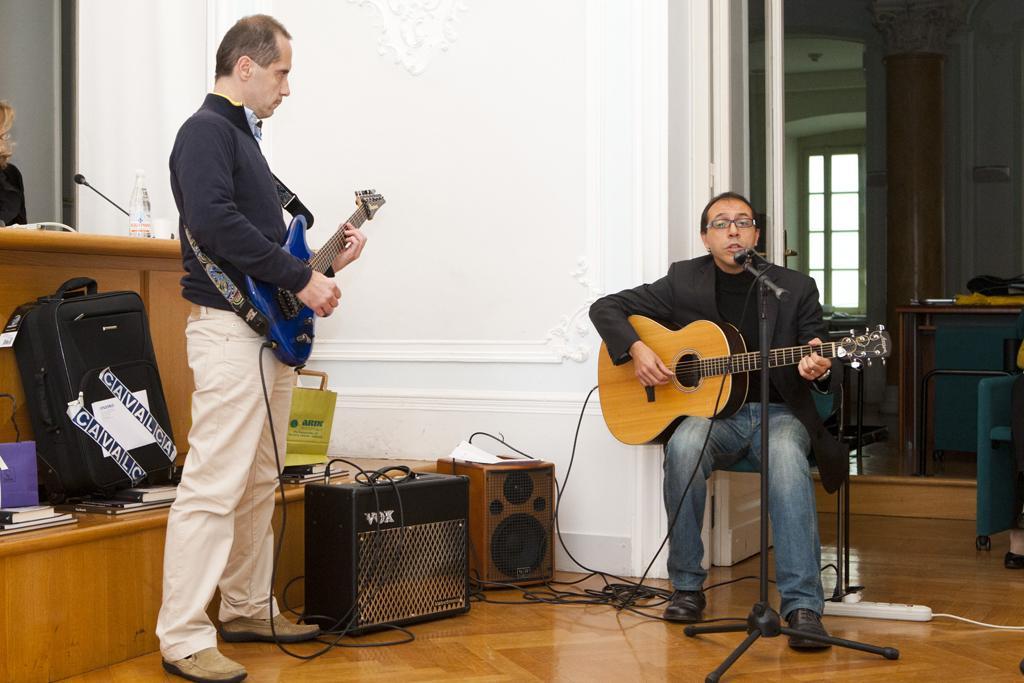In one or two sentences, can you explain what this image depicts? This picture is of inside the room. On the right there is a man sitting on the chair, playing guitar and singing. There is a microphone attached to the stand. In the center there is a speaker and some instrument. On the left there is a man standing and playing guitar. There is a bag and some books placed in front of the table. On the left corner there is a table on the top of which a microphone and a bottle is placed. In the background we can see a person, a wall, window, pillar and a table on the top of which some items are placed. 